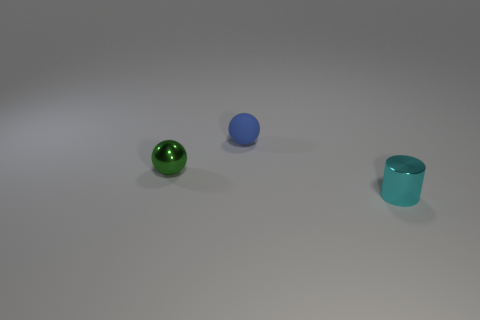What number of objects are on the left side of the cyan object?
Give a very brief answer. 2. Is there another small thing made of the same material as the small cyan thing?
Ensure brevity in your answer.  Yes. What color is the tiny shiny thing behind the cyan metallic object?
Your answer should be compact. Green. Is the number of matte objects that are in front of the metal ball the same as the number of metal cylinders that are to the left of the cyan cylinder?
Your response must be concise. Yes. What material is the ball that is behind the tiny shiny object left of the tiny rubber ball?
Give a very brief answer. Rubber. How many things are either tiny cyan cylinders or objects in front of the small green object?
Give a very brief answer. 1. There is another thing that is the same material as the tiny green object; what size is it?
Offer a terse response. Small. Is the number of cyan shiny objects that are in front of the metal ball greater than the number of big green rubber cubes?
Provide a succinct answer. Yes. What material is the other thing that is the same shape as the tiny matte thing?
Make the answer very short. Metal. What is the color of the small thing that is in front of the small blue ball and to the right of the tiny green metallic ball?
Make the answer very short. Cyan. 